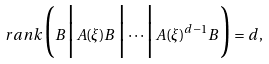Convert formula to latex. <formula><loc_0><loc_0><loc_500><loc_500>\ r a n k \Big ( B \Big | A ( \xi ) B \Big | \cdots \Big | A ( \xi ) ^ { d - 1 } B \Big ) = d ,</formula> 